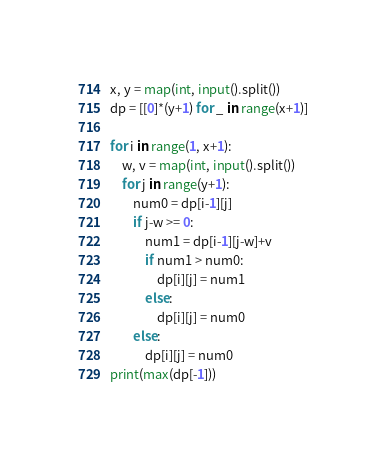Convert code to text. <code><loc_0><loc_0><loc_500><loc_500><_Python_>x, y = map(int, input().split())
dp = [[0]*(y+1) for _ in range(x+1)]

for i in range(1, x+1):
    w, v = map(int, input().split())
    for j in range(y+1):
        num0 = dp[i-1][j]
        if j-w >= 0:
            num1 = dp[i-1][j-w]+v
            if num1 > num0:
                dp[i][j] = num1
            else:
                dp[i][j] = num0
        else:
            dp[i][j] = num0
print(max(dp[-1]))
</code> 